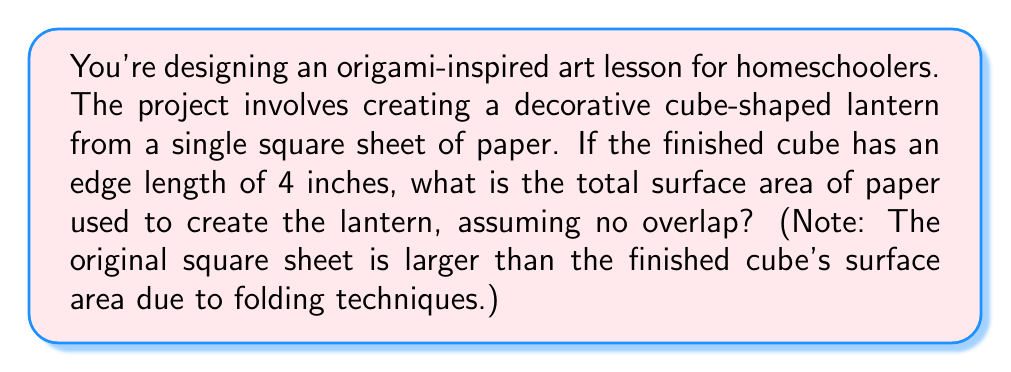Can you solve this math problem? Let's approach this step-by-step:

1) First, we need to understand what we're calculating. We're looking for the surface area of the original square sheet of paper.

2) The finished product is a cube with an edge length of 4 inches. Let's calculate its surface area:
   $$\text{Surface Area of Cube} = 6 \times \text{(side length)}^2$$
   $$= 6 \times 4^2 = 6 \times 16 = 96 \text{ square inches}$$

3) However, this is not our final answer. The original sheet must be larger to account for the folding techniques used in origami.

4) In origami, to create a cube, you typically start with a square sheet that has sides equal to the cube's surface area.

5) So, we need to find the side length of a square with an area of 96 square inches:
   $$\text{Area of Square} = \text{side length}^2$$
   $$96 = s^2$$
   $$s = \sqrt{96} = 4\sqrt{6} \approx 9.8 \text{ inches}$$

6) Now that we have the side length of the original square, we can calculate its area:
   $$\text{Area of Original Square} = (4\sqrt{6})^2 = 16 \times 6 = 96 \text{ square inches}$$

Therefore, the total surface area of paper used is 96 square inches, which interestingly is the same as the surface area of the finished cube.
Answer: 96 square inches 